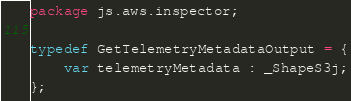<code> <loc_0><loc_0><loc_500><loc_500><_Haxe_>package js.aws.inspector;

typedef GetTelemetryMetadataOutput = {
    var telemetryMetadata : _ShapeS3j;
};
</code> 